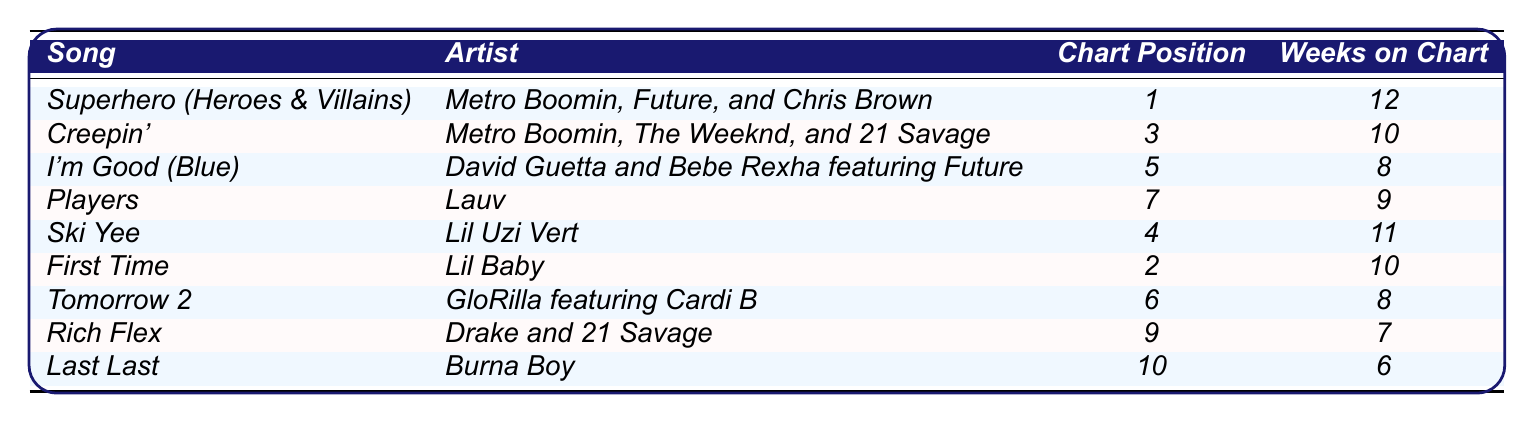What is the chart position of "First Time"? The chart position for "First Time" is provided directly in the table, which lists it as *2*.
Answer: 2 Who are the artists for "Ski Yee"? The table specifies that "Ski Yee" is by *Lil Uzi Vert*.
Answer: Lil Uzi Vert Which song spent the most weeks on the chart? By comparing the "Weeks on Chart" column, *Superhero (Heroes & Villains)* spent *12 weeks* on the chart, which is the highest among all songs listed.
Answer: Superhero (Heroes & Villains) Is "Creepin'" performed by Metro Boomin? The table confirms that *Creepin'* is performed by *Metro Boomin, The Weeknd, and 21 Savage*, meaning yes, Metro Boomin is involved.
Answer: Yes What is the average chart position for the songs listed? The total chart positions sum up to 1 + 3 + 5 + 7 + 4 + 2 + 6 + 9 + 10 = 47. There are 9 songs, so the average is 47/9 ≈ 5.22.
Answer: 5.22 How many songs in the table stayed on the chart for more than 10 weeks? Only *Superhero (Heroes & Villains)* at 12 weeks is above 10 weeks. Thus, there is only 1 song that fits this criterion.
Answer: 1 Which song has the lowest chart position? Looking at the "Chart Position" column, *Last Last* has the lowest position at *10*.
Answer: Last Last What is the difference in weeks on the chart between "I'm Good (Blue)" and "Tomorrow 2"? "I'm Good (Blue)" has *8 weeks*, and "Tomorrow 2" has *8 weeks* as well. Therefore, the difference is 8 - 8 = 0 weeks.
Answer: 0 Which artist has a song that is in the top 5 and also features a prominent rapper? *First Time* by *Lil Baby* is in the top 5 at position *2*, which features *Lil Baby*, a renowned rapper.
Answer: Lil Baby How many artists are involved in the song "Rich Flex"? The table lists *Rich Flex* as being by *Drake and 21 Savage*, which means there are 2 artists involved.
Answer: 2 